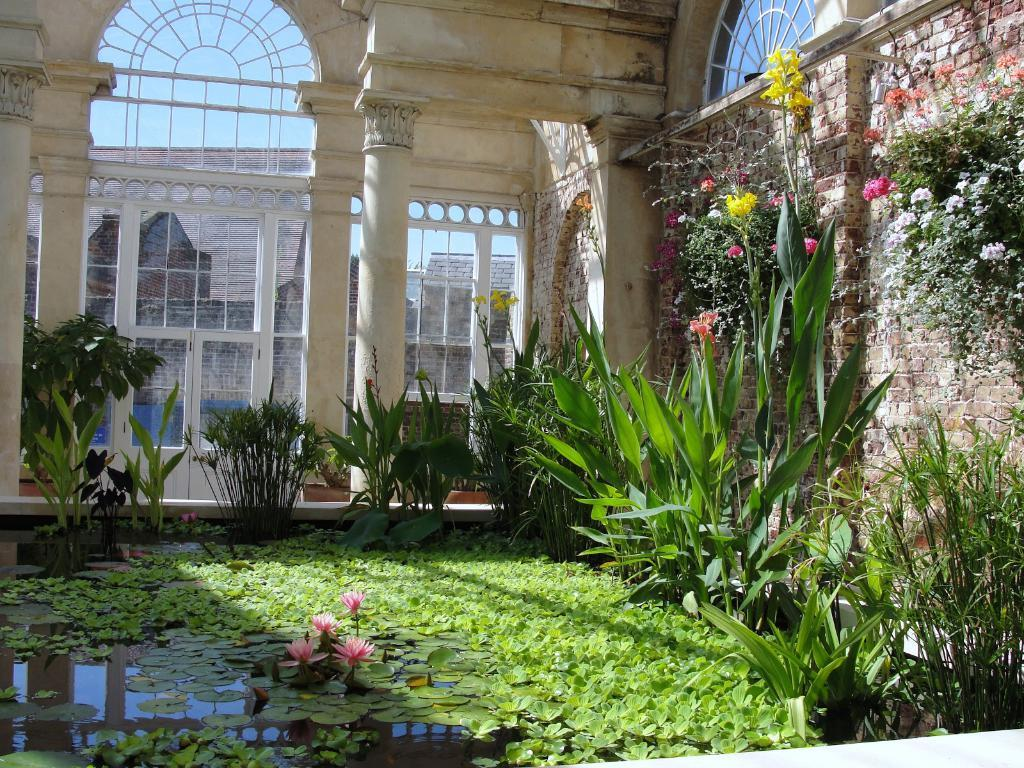What is floating on the water in the image? There are leaves and flowers on the water in the image. What type of natural elements are present in the image? There are plants in the image. What type of man-made structures can be seen in the image? There are buildings in the image. What is visible in the background of the image? The sky is visible in the background of the image. Where is the ring located in the image? There is no ring present in the image. What type of boy can be seen playing with the plants in the image? There is no boy present in the image. 